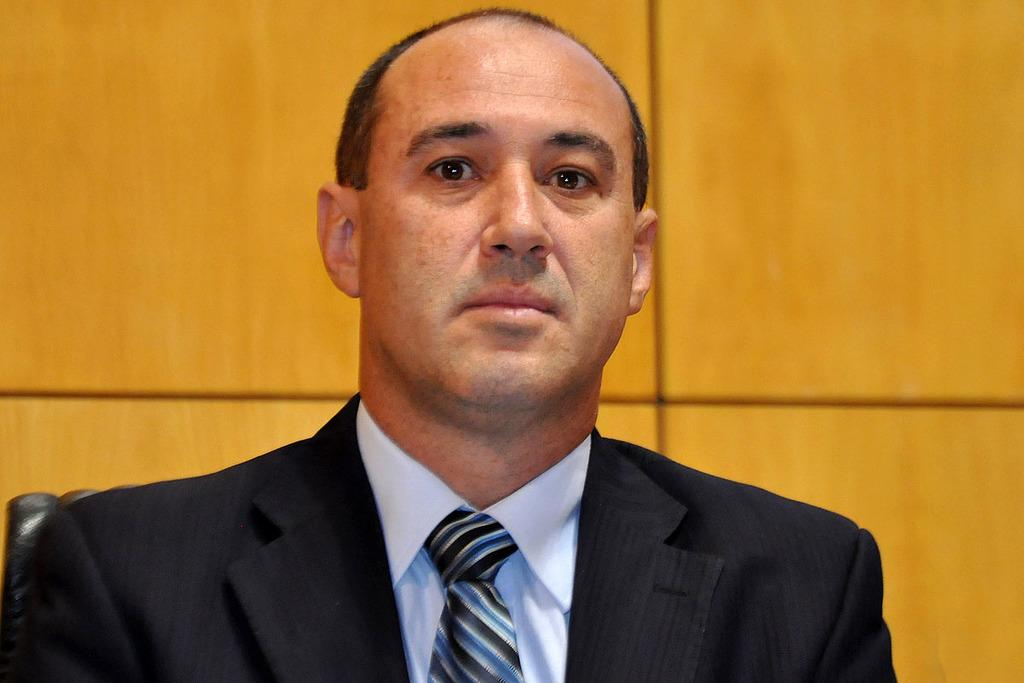What is present in the image? There is a person in the image. What is the person wearing? The person is wearing a suit. What can be seen in the background of the image? There is a wall in the background of the image. What type of hat is the person wearing in the image? There is no hat visible in the image; the person is wearing a suit. Is the person playing a guitar in the image? There is no guitar present in the image. 